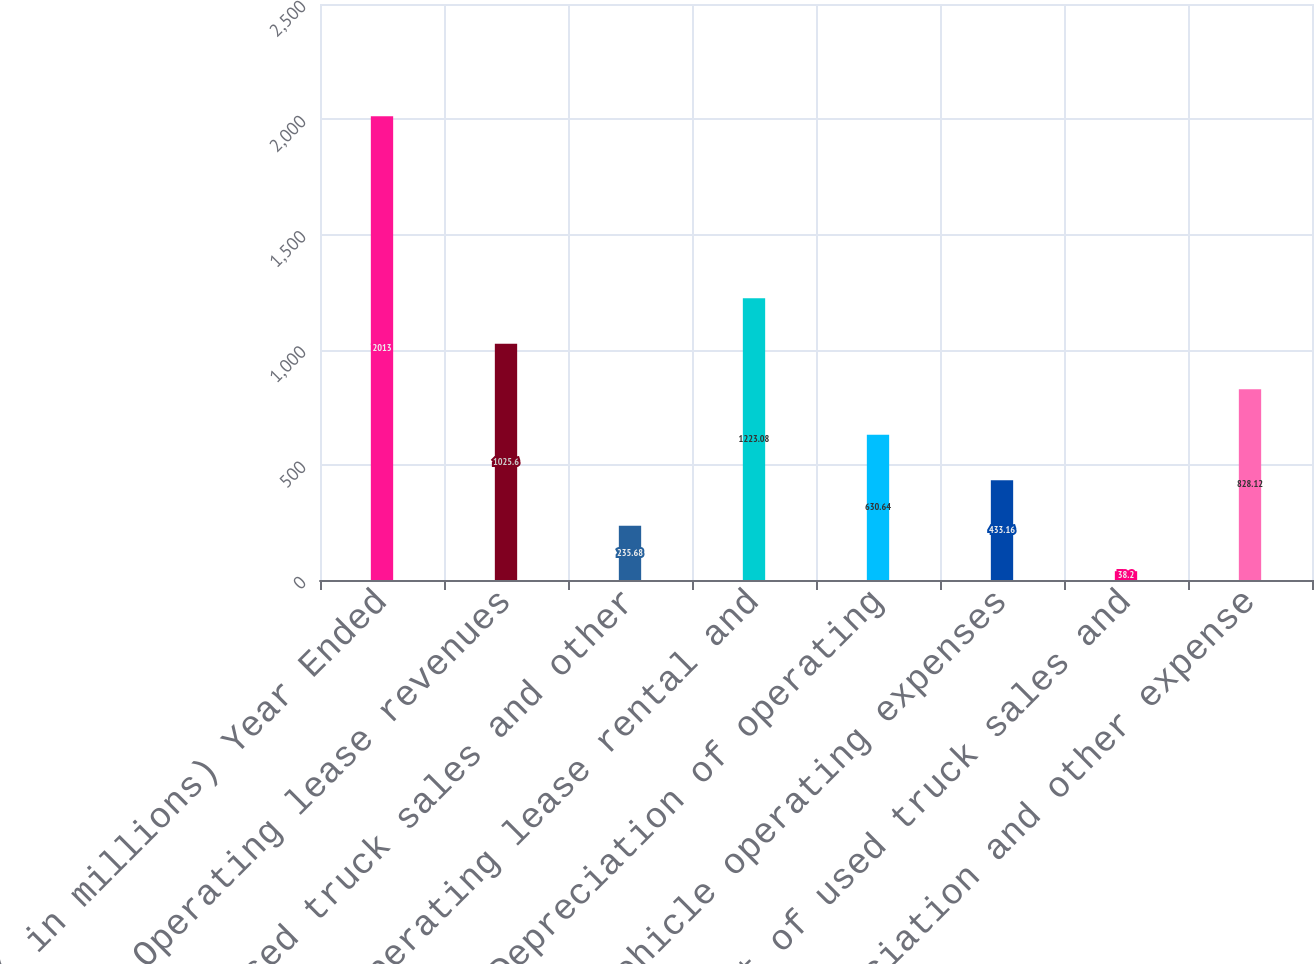Convert chart to OTSL. <chart><loc_0><loc_0><loc_500><loc_500><bar_chart><fcel>( in millions) Year Ended<fcel>Operating lease revenues<fcel>Used truck sales and other<fcel>Operating lease rental and<fcel>Depreciation of operating<fcel>Vehicle operating expenses<fcel>Cost of used truck sales and<fcel>Depreciation and other expense<nl><fcel>2013<fcel>1025.6<fcel>235.68<fcel>1223.08<fcel>630.64<fcel>433.16<fcel>38.2<fcel>828.12<nl></chart> 